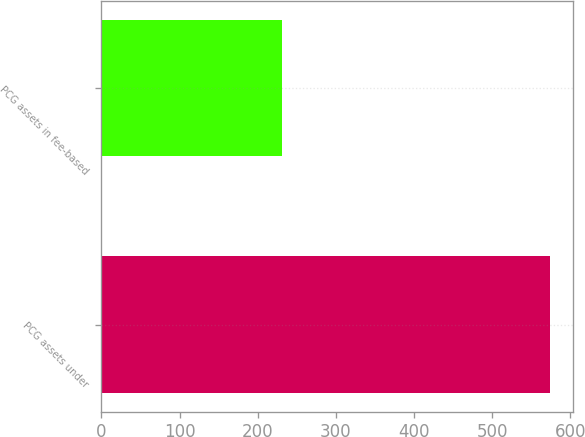Convert chart. <chart><loc_0><loc_0><loc_500><loc_500><bar_chart><fcel>PCG assets under<fcel>PCG assets in fee-based<nl><fcel>574.1<fcel>231<nl></chart> 